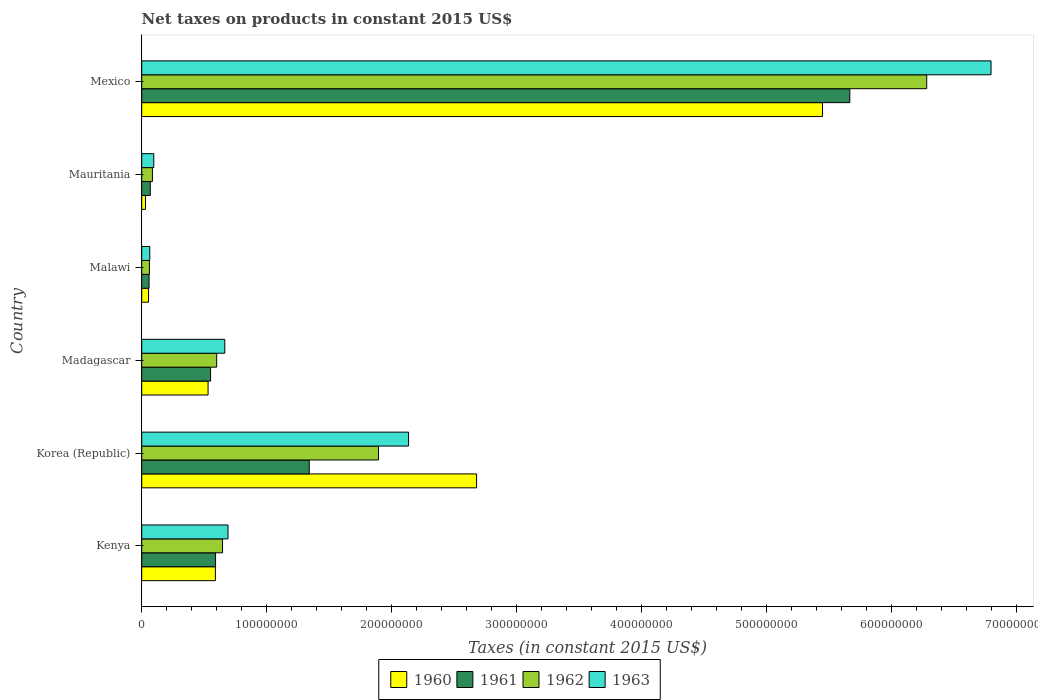How many groups of bars are there?
Provide a succinct answer. 6. Are the number of bars per tick equal to the number of legend labels?
Ensure brevity in your answer.  Yes. How many bars are there on the 6th tick from the top?
Offer a terse response. 4. How many bars are there on the 2nd tick from the bottom?
Keep it short and to the point. 4. In how many cases, is the number of bars for a given country not equal to the number of legend labels?
Keep it short and to the point. 0. What is the net taxes on products in 1960 in Mauritania?
Your answer should be compact. 3.00e+06. Across all countries, what is the maximum net taxes on products in 1962?
Your answer should be very brief. 6.28e+08. Across all countries, what is the minimum net taxes on products in 1960?
Keep it short and to the point. 3.00e+06. In which country was the net taxes on products in 1960 maximum?
Make the answer very short. Mexico. In which country was the net taxes on products in 1960 minimum?
Offer a terse response. Mauritania. What is the total net taxes on products in 1961 in the graph?
Make the answer very short. 8.27e+08. What is the difference between the net taxes on products in 1961 in Madagascar and that in Malawi?
Your answer should be very brief. 4.92e+07. What is the difference between the net taxes on products in 1961 in Korea (Republic) and the net taxes on products in 1962 in Madagascar?
Provide a succinct answer. 7.41e+07. What is the average net taxes on products in 1960 per country?
Give a very brief answer. 1.55e+08. What is the difference between the net taxes on products in 1962 and net taxes on products in 1960 in Kenya?
Your answer should be very brief. 5.73e+06. What is the ratio of the net taxes on products in 1961 in Malawi to that in Mexico?
Your answer should be compact. 0.01. Is the net taxes on products in 1960 in Madagascar less than that in Mauritania?
Offer a very short reply. No. What is the difference between the highest and the second highest net taxes on products in 1963?
Make the answer very short. 4.66e+08. What is the difference between the highest and the lowest net taxes on products in 1962?
Offer a very short reply. 6.22e+08. In how many countries, is the net taxes on products in 1962 greater than the average net taxes on products in 1962 taken over all countries?
Provide a short and direct response. 2. Is the sum of the net taxes on products in 1961 in Mauritania and Mexico greater than the maximum net taxes on products in 1960 across all countries?
Give a very brief answer. Yes. What does the 3rd bar from the top in Madagascar represents?
Your response must be concise. 1961. What does the 2nd bar from the bottom in Kenya represents?
Your response must be concise. 1961. Is it the case that in every country, the sum of the net taxes on products in 1962 and net taxes on products in 1963 is greater than the net taxes on products in 1960?
Ensure brevity in your answer.  Yes. How many bars are there?
Give a very brief answer. 24. What is the difference between two consecutive major ticks on the X-axis?
Make the answer very short. 1.00e+08. Does the graph contain any zero values?
Provide a succinct answer. No. Does the graph contain grids?
Give a very brief answer. No. Where does the legend appear in the graph?
Your response must be concise. Bottom center. How are the legend labels stacked?
Your answer should be very brief. Horizontal. What is the title of the graph?
Your answer should be very brief. Net taxes on products in constant 2015 US$. Does "2000" appear as one of the legend labels in the graph?
Provide a short and direct response. No. What is the label or title of the X-axis?
Keep it short and to the point. Taxes (in constant 2015 US$). What is the label or title of the Y-axis?
Offer a very short reply. Country. What is the Taxes (in constant 2015 US$) of 1960 in Kenya?
Give a very brief answer. 5.89e+07. What is the Taxes (in constant 2015 US$) of 1961 in Kenya?
Ensure brevity in your answer.  5.91e+07. What is the Taxes (in constant 2015 US$) of 1962 in Kenya?
Offer a very short reply. 6.47e+07. What is the Taxes (in constant 2015 US$) in 1963 in Kenya?
Ensure brevity in your answer.  6.90e+07. What is the Taxes (in constant 2015 US$) of 1960 in Korea (Republic)?
Make the answer very short. 2.68e+08. What is the Taxes (in constant 2015 US$) of 1961 in Korea (Republic)?
Keep it short and to the point. 1.34e+08. What is the Taxes (in constant 2015 US$) in 1962 in Korea (Republic)?
Keep it short and to the point. 1.89e+08. What is the Taxes (in constant 2015 US$) in 1963 in Korea (Republic)?
Your answer should be very brief. 2.13e+08. What is the Taxes (in constant 2015 US$) of 1960 in Madagascar?
Keep it short and to the point. 5.31e+07. What is the Taxes (in constant 2015 US$) in 1961 in Madagascar?
Offer a very short reply. 5.51e+07. What is the Taxes (in constant 2015 US$) in 1962 in Madagascar?
Keep it short and to the point. 6.00e+07. What is the Taxes (in constant 2015 US$) of 1963 in Madagascar?
Ensure brevity in your answer.  6.64e+07. What is the Taxes (in constant 2015 US$) in 1960 in Malawi?
Ensure brevity in your answer.  5.46e+06. What is the Taxes (in constant 2015 US$) of 1961 in Malawi?
Your answer should be compact. 5.88e+06. What is the Taxes (in constant 2015 US$) in 1962 in Malawi?
Provide a succinct answer. 6.16e+06. What is the Taxes (in constant 2015 US$) in 1963 in Malawi?
Make the answer very short. 6.44e+06. What is the Taxes (in constant 2015 US$) of 1960 in Mauritania?
Your response must be concise. 3.00e+06. What is the Taxes (in constant 2015 US$) of 1961 in Mauritania?
Offer a terse response. 6.85e+06. What is the Taxes (in constant 2015 US$) in 1962 in Mauritania?
Offer a terse response. 8.56e+06. What is the Taxes (in constant 2015 US$) of 1963 in Mauritania?
Make the answer very short. 9.63e+06. What is the Taxes (in constant 2015 US$) of 1960 in Mexico?
Give a very brief answer. 5.45e+08. What is the Taxes (in constant 2015 US$) of 1961 in Mexico?
Provide a succinct answer. 5.66e+08. What is the Taxes (in constant 2015 US$) in 1962 in Mexico?
Your response must be concise. 6.28e+08. What is the Taxes (in constant 2015 US$) of 1963 in Mexico?
Provide a succinct answer. 6.79e+08. Across all countries, what is the maximum Taxes (in constant 2015 US$) of 1960?
Offer a very short reply. 5.45e+08. Across all countries, what is the maximum Taxes (in constant 2015 US$) of 1961?
Ensure brevity in your answer.  5.66e+08. Across all countries, what is the maximum Taxes (in constant 2015 US$) of 1962?
Your answer should be compact. 6.28e+08. Across all countries, what is the maximum Taxes (in constant 2015 US$) in 1963?
Make the answer very short. 6.79e+08. Across all countries, what is the minimum Taxes (in constant 2015 US$) in 1960?
Provide a succinct answer. 3.00e+06. Across all countries, what is the minimum Taxes (in constant 2015 US$) of 1961?
Ensure brevity in your answer.  5.88e+06. Across all countries, what is the minimum Taxes (in constant 2015 US$) of 1962?
Give a very brief answer. 6.16e+06. Across all countries, what is the minimum Taxes (in constant 2015 US$) in 1963?
Make the answer very short. 6.44e+06. What is the total Taxes (in constant 2015 US$) in 1960 in the graph?
Your answer should be compact. 9.33e+08. What is the total Taxes (in constant 2015 US$) of 1961 in the graph?
Offer a terse response. 8.27e+08. What is the total Taxes (in constant 2015 US$) of 1962 in the graph?
Give a very brief answer. 9.57e+08. What is the total Taxes (in constant 2015 US$) of 1963 in the graph?
Your answer should be compact. 1.04e+09. What is the difference between the Taxes (in constant 2015 US$) in 1960 in Kenya and that in Korea (Republic)?
Provide a short and direct response. -2.09e+08. What is the difference between the Taxes (in constant 2015 US$) of 1961 in Kenya and that in Korea (Republic)?
Give a very brief answer. -7.49e+07. What is the difference between the Taxes (in constant 2015 US$) in 1962 in Kenya and that in Korea (Republic)?
Offer a terse response. -1.25e+08. What is the difference between the Taxes (in constant 2015 US$) of 1963 in Kenya and that in Korea (Republic)?
Provide a succinct answer. -1.44e+08. What is the difference between the Taxes (in constant 2015 US$) in 1960 in Kenya and that in Madagascar?
Provide a short and direct response. 5.86e+06. What is the difference between the Taxes (in constant 2015 US$) in 1961 in Kenya and that in Madagascar?
Your answer should be compact. 3.97e+06. What is the difference between the Taxes (in constant 2015 US$) of 1962 in Kenya and that in Madagascar?
Your response must be concise. 4.70e+06. What is the difference between the Taxes (in constant 2015 US$) of 1963 in Kenya and that in Madagascar?
Your response must be concise. 2.58e+06. What is the difference between the Taxes (in constant 2015 US$) of 1960 in Kenya and that in Malawi?
Your response must be concise. 5.35e+07. What is the difference between the Taxes (in constant 2015 US$) of 1961 in Kenya and that in Malawi?
Ensure brevity in your answer.  5.32e+07. What is the difference between the Taxes (in constant 2015 US$) of 1962 in Kenya and that in Malawi?
Give a very brief answer. 5.85e+07. What is the difference between the Taxes (in constant 2015 US$) in 1963 in Kenya and that in Malawi?
Make the answer very short. 6.26e+07. What is the difference between the Taxes (in constant 2015 US$) in 1960 in Kenya and that in Mauritania?
Provide a short and direct response. 5.59e+07. What is the difference between the Taxes (in constant 2015 US$) in 1961 in Kenya and that in Mauritania?
Give a very brief answer. 5.22e+07. What is the difference between the Taxes (in constant 2015 US$) of 1962 in Kenya and that in Mauritania?
Offer a terse response. 5.61e+07. What is the difference between the Taxes (in constant 2015 US$) in 1963 in Kenya and that in Mauritania?
Offer a very short reply. 5.94e+07. What is the difference between the Taxes (in constant 2015 US$) of 1960 in Kenya and that in Mexico?
Your response must be concise. -4.86e+08. What is the difference between the Taxes (in constant 2015 US$) in 1961 in Kenya and that in Mexico?
Your response must be concise. -5.07e+08. What is the difference between the Taxes (in constant 2015 US$) of 1962 in Kenya and that in Mexico?
Make the answer very short. -5.63e+08. What is the difference between the Taxes (in constant 2015 US$) in 1963 in Kenya and that in Mexico?
Your answer should be very brief. -6.10e+08. What is the difference between the Taxes (in constant 2015 US$) of 1960 in Korea (Republic) and that in Madagascar?
Make the answer very short. 2.15e+08. What is the difference between the Taxes (in constant 2015 US$) of 1961 in Korea (Republic) and that in Madagascar?
Keep it short and to the point. 7.89e+07. What is the difference between the Taxes (in constant 2015 US$) of 1962 in Korea (Republic) and that in Madagascar?
Offer a terse response. 1.29e+08. What is the difference between the Taxes (in constant 2015 US$) in 1963 in Korea (Republic) and that in Madagascar?
Provide a short and direct response. 1.47e+08. What is the difference between the Taxes (in constant 2015 US$) of 1960 in Korea (Republic) and that in Malawi?
Your answer should be very brief. 2.62e+08. What is the difference between the Taxes (in constant 2015 US$) in 1961 in Korea (Republic) and that in Malawi?
Provide a succinct answer. 1.28e+08. What is the difference between the Taxes (in constant 2015 US$) in 1962 in Korea (Republic) and that in Malawi?
Offer a terse response. 1.83e+08. What is the difference between the Taxes (in constant 2015 US$) of 1963 in Korea (Republic) and that in Malawi?
Offer a very short reply. 2.07e+08. What is the difference between the Taxes (in constant 2015 US$) of 1960 in Korea (Republic) and that in Mauritania?
Provide a succinct answer. 2.65e+08. What is the difference between the Taxes (in constant 2015 US$) in 1961 in Korea (Republic) and that in Mauritania?
Ensure brevity in your answer.  1.27e+08. What is the difference between the Taxes (in constant 2015 US$) of 1962 in Korea (Republic) and that in Mauritania?
Your answer should be compact. 1.81e+08. What is the difference between the Taxes (in constant 2015 US$) in 1963 in Korea (Republic) and that in Mauritania?
Keep it short and to the point. 2.04e+08. What is the difference between the Taxes (in constant 2015 US$) in 1960 in Korea (Republic) and that in Mexico?
Your response must be concise. -2.77e+08. What is the difference between the Taxes (in constant 2015 US$) of 1961 in Korea (Republic) and that in Mexico?
Your answer should be very brief. -4.32e+08. What is the difference between the Taxes (in constant 2015 US$) in 1962 in Korea (Republic) and that in Mexico?
Your answer should be very brief. -4.38e+08. What is the difference between the Taxes (in constant 2015 US$) in 1963 in Korea (Republic) and that in Mexico?
Your answer should be very brief. -4.66e+08. What is the difference between the Taxes (in constant 2015 US$) of 1960 in Madagascar and that in Malawi?
Your response must be concise. 4.76e+07. What is the difference between the Taxes (in constant 2015 US$) of 1961 in Madagascar and that in Malawi?
Keep it short and to the point. 4.92e+07. What is the difference between the Taxes (in constant 2015 US$) of 1962 in Madagascar and that in Malawi?
Offer a very short reply. 5.38e+07. What is the difference between the Taxes (in constant 2015 US$) of 1963 in Madagascar and that in Malawi?
Make the answer very short. 6.00e+07. What is the difference between the Taxes (in constant 2015 US$) in 1960 in Madagascar and that in Mauritania?
Your response must be concise. 5.01e+07. What is the difference between the Taxes (in constant 2015 US$) in 1961 in Madagascar and that in Mauritania?
Provide a short and direct response. 4.82e+07. What is the difference between the Taxes (in constant 2015 US$) in 1962 in Madagascar and that in Mauritania?
Your answer should be very brief. 5.14e+07. What is the difference between the Taxes (in constant 2015 US$) in 1963 in Madagascar and that in Mauritania?
Keep it short and to the point. 5.68e+07. What is the difference between the Taxes (in constant 2015 US$) of 1960 in Madagascar and that in Mexico?
Offer a very short reply. -4.91e+08. What is the difference between the Taxes (in constant 2015 US$) of 1961 in Madagascar and that in Mexico?
Offer a very short reply. -5.11e+08. What is the difference between the Taxes (in constant 2015 US$) of 1962 in Madagascar and that in Mexico?
Your answer should be compact. -5.68e+08. What is the difference between the Taxes (in constant 2015 US$) of 1963 in Madagascar and that in Mexico?
Provide a short and direct response. -6.13e+08. What is the difference between the Taxes (in constant 2015 US$) in 1960 in Malawi and that in Mauritania?
Ensure brevity in your answer.  2.46e+06. What is the difference between the Taxes (in constant 2015 US$) in 1961 in Malawi and that in Mauritania?
Provide a succinct answer. -9.67e+05. What is the difference between the Taxes (in constant 2015 US$) in 1962 in Malawi and that in Mauritania?
Offer a terse response. -2.40e+06. What is the difference between the Taxes (in constant 2015 US$) of 1963 in Malawi and that in Mauritania?
Make the answer very short. -3.19e+06. What is the difference between the Taxes (in constant 2015 US$) in 1960 in Malawi and that in Mexico?
Make the answer very short. -5.39e+08. What is the difference between the Taxes (in constant 2015 US$) in 1961 in Malawi and that in Mexico?
Offer a very short reply. -5.61e+08. What is the difference between the Taxes (in constant 2015 US$) of 1962 in Malawi and that in Mexico?
Provide a short and direct response. -6.22e+08. What is the difference between the Taxes (in constant 2015 US$) in 1963 in Malawi and that in Mexico?
Provide a succinct answer. -6.73e+08. What is the difference between the Taxes (in constant 2015 US$) in 1960 in Mauritania and that in Mexico?
Offer a very short reply. -5.42e+08. What is the difference between the Taxes (in constant 2015 US$) of 1961 in Mauritania and that in Mexico?
Your answer should be compact. -5.60e+08. What is the difference between the Taxes (in constant 2015 US$) in 1962 in Mauritania and that in Mexico?
Ensure brevity in your answer.  -6.19e+08. What is the difference between the Taxes (in constant 2015 US$) of 1963 in Mauritania and that in Mexico?
Offer a terse response. -6.70e+08. What is the difference between the Taxes (in constant 2015 US$) in 1960 in Kenya and the Taxes (in constant 2015 US$) in 1961 in Korea (Republic)?
Ensure brevity in your answer.  -7.51e+07. What is the difference between the Taxes (in constant 2015 US$) in 1960 in Kenya and the Taxes (in constant 2015 US$) in 1962 in Korea (Republic)?
Ensure brevity in your answer.  -1.31e+08. What is the difference between the Taxes (in constant 2015 US$) in 1960 in Kenya and the Taxes (in constant 2015 US$) in 1963 in Korea (Republic)?
Provide a short and direct response. -1.55e+08. What is the difference between the Taxes (in constant 2015 US$) in 1961 in Kenya and the Taxes (in constant 2015 US$) in 1962 in Korea (Republic)?
Your answer should be compact. -1.30e+08. What is the difference between the Taxes (in constant 2015 US$) in 1961 in Kenya and the Taxes (in constant 2015 US$) in 1963 in Korea (Republic)?
Provide a short and direct response. -1.54e+08. What is the difference between the Taxes (in constant 2015 US$) of 1962 in Kenya and the Taxes (in constant 2015 US$) of 1963 in Korea (Republic)?
Provide a short and direct response. -1.49e+08. What is the difference between the Taxes (in constant 2015 US$) in 1960 in Kenya and the Taxes (in constant 2015 US$) in 1961 in Madagascar?
Provide a short and direct response. 3.83e+06. What is the difference between the Taxes (in constant 2015 US$) in 1960 in Kenya and the Taxes (in constant 2015 US$) in 1962 in Madagascar?
Ensure brevity in your answer.  -1.03e+06. What is the difference between the Taxes (in constant 2015 US$) in 1960 in Kenya and the Taxes (in constant 2015 US$) in 1963 in Madagascar?
Provide a short and direct response. -7.51e+06. What is the difference between the Taxes (in constant 2015 US$) in 1961 in Kenya and the Taxes (in constant 2015 US$) in 1962 in Madagascar?
Ensure brevity in your answer.  -8.90e+05. What is the difference between the Taxes (in constant 2015 US$) in 1961 in Kenya and the Taxes (in constant 2015 US$) in 1963 in Madagascar?
Ensure brevity in your answer.  -7.37e+06. What is the difference between the Taxes (in constant 2015 US$) of 1962 in Kenya and the Taxes (in constant 2015 US$) of 1963 in Madagascar?
Offer a very short reply. -1.79e+06. What is the difference between the Taxes (in constant 2015 US$) of 1960 in Kenya and the Taxes (in constant 2015 US$) of 1961 in Malawi?
Keep it short and to the point. 5.30e+07. What is the difference between the Taxes (in constant 2015 US$) of 1960 in Kenya and the Taxes (in constant 2015 US$) of 1962 in Malawi?
Your response must be concise. 5.28e+07. What is the difference between the Taxes (in constant 2015 US$) of 1960 in Kenya and the Taxes (in constant 2015 US$) of 1963 in Malawi?
Offer a terse response. 5.25e+07. What is the difference between the Taxes (in constant 2015 US$) in 1961 in Kenya and the Taxes (in constant 2015 US$) in 1962 in Malawi?
Give a very brief answer. 5.29e+07. What is the difference between the Taxes (in constant 2015 US$) in 1961 in Kenya and the Taxes (in constant 2015 US$) in 1963 in Malawi?
Make the answer very short. 5.26e+07. What is the difference between the Taxes (in constant 2015 US$) in 1962 in Kenya and the Taxes (in constant 2015 US$) in 1963 in Malawi?
Keep it short and to the point. 5.82e+07. What is the difference between the Taxes (in constant 2015 US$) in 1960 in Kenya and the Taxes (in constant 2015 US$) in 1961 in Mauritania?
Ensure brevity in your answer.  5.21e+07. What is the difference between the Taxes (in constant 2015 US$) of 1960 in Kenya and the Taxes (in constant 2015 US$) of 1962 in Mauritania?
Your answer should be compact. 5.04e+07. What is the difference between the Taxes (in constant 2015 US$) of 1960 in Kenya and the Taxes (in constant 2015 US$) of 1963 in Mauritania?
Offer a terse response. 4.93e+07. What is the difference between the Taxes (in constant 2015 US$) of 1961 in Kenya and the Taxes (in constant 2015 US$) of 1962 in Mauritania?
Keep it short and to the point. 5.05e+07. What is the difference between the Taxes (in constant 2015 US$) in 1961 in Kenya and the Taxes (in constant 2015 US$) in 1963 in Mauritania?
Make the answer very short. 4.94e+07. What is the difference between the Taxes (in constant 2015 US$) in 1962 in Kenya and the Taxes (in constant 2015 US$) in 1963 in Mauritania?
Offer a very short reply. 5.50e+07. What is the difference between the Taxes (in constant 2015 US$) of 1960 in Kenya and the Taxes (in constant 2015 US$) of 1961 in Mexico?
Provide a succinct answer. -5.07e+08. What is the difference between the Taxes (in constant 2015 US$) in 1960 in Kenya and the Taxes (in constant 2015 US$) in 1962 in Mexico?
Ensure brevity in your answer.  -5.69e+08. What is the difference between the Taxes (in constant 2015 US$) in 1960 in Kenya and the Taxes (in constant 2015 US$) in 1963 in Mexico?
Offer a very short reply. -6.20e+08. What is the difference between the Taxes (in constant 2015 US$) of 1961 in Kenya and the Taxes (in constant 2015 US$) of 1962 in Mexico?
Your response must be concise. -5.69e+08. What is the difference between the Taxes (in constant 2015 US$) in 1961 in Kenya and the Taxes (in constant 2015 US$) in 1963 in Mexico?
Give a very brief answer. -6.20e+08. What is the difference between the Taxes (in constant 2015 US$) of 1962 in Kenya and the Taxes (in constant 2015 US$) of 1963 in Mexico?
Your answer should be very brief. -6.15e+08. What is the difference between the Taxes (in constant 2015 US$) of 1960 in Korea (Republic) and the Taxes (in constant 2015 US$) of 1961 in Madagascar?
Your answer should be very brief. 2.13e+08. What is the difference between the Taxes (in constant 2015 US$) of 1960 in Korea (Republic) and the Taxes (in constant 2015 US$) of 1962 in Madagascar?
Provide a short and direct response. 2.08e+08. What is the difference between the Taxes (in constant 2015 US$) of 1960 in Korea (Republic) and the Taxes (in constant 2015 US$) of 1963 in Madagascar?
Give a very brief answer. 2.01e+08. What is the difference between the Taxes (in constant 2015 US$) in 1961 in Korea (Republic) and the Taxes (in constant 2015 US$) in 1962 in Madagascar?
Provide a succinct answer. 7.41e+07. What is the difference between the Taxes (in constant 2015 US$) of 1961 in Korea (Republic) and the Taxes (in constant 2015 US$) of 1963 in Madagascar?
Offer a very short reply. 6.76e+07. What is the difference between the Taxes (in constant 2015 US$) of 1962 in Korea (Republic) and the Taxes (in constant 2015 US$) of 1963 in Madagascar?
Give a very brief answer. 1.23e+08. What is the difference between the Taxes (in constant 2015 US$) in 1960 in Korea (Republic) and the Taxes (in constant 2015 US$) in 1961 in Malawi?
Ensure brevity in your answer.  2.62e+08. What is the difference between the Taxes (in constant 2015 US$) of 1960 in Korea (Republic) and the Taxes (in constant 2015 US$) of 1962 in Malawi?
Keep it short and to the point. 2.62e+08. What is the difference between the Taxes (in constant 2015 US$) in 1960 in Korea (Republic) and the Taxes (in constant 2015 US$) in 1963 in Malawi?
Your response must be concise. 2.61e+08. What is the difference between the Taxes (in constant 2015 US$) of 1961 in Korea (Republic) and the Taxes (in constant 2015 US$) of 1962 in Malawi?
Your answer should be compact. 1.28e+08. What is the difference between the Taxes (in constant 2015 US$) of 1961 in Korea (Republic) and the Taxes (in constant 2015 US$) of 1963 in Malawi?
Provide a succinct answer. 1.28e+08. What is the difference between the Taxes (in constant 2015 US$) of 1962 in Korea (Republic) and the Taxes (in constant 2015 US$) of 1963 in Malawi?
Your answer should be compact. 1.83e+08. What is the difference between the Taxes (in constant 2015 US$) in 1960 in Korea (Republic) and the Taxes (in constant 2015 US$) in 1961 in Mauritania?
Your answer should be very brief. 2.61e+08. What is the difference between the Taxes (in constant 2015 US$) in 1960 in Korea (Republic) and the Taxes (in constant 2015 US$) in 1962 in Mauritania?
Your answer should be compact. 2.59e+08. What is the difference between the Taxes (in constant 2015 US$) in 1960 in Korea (Republic) and the Taxes (in constant 2015 US$) in 1963 in Mauritania?
Keep it short and to the point. 2.58e+08. What is the difference between the Taxes (in constant 2015 US$) in 1961 in Korea (Republic) and the Taxes (in constant 2015 US$) in 1962 in Mauritania?
Offer a very short reply. 1.25e+08. What is the difference between the Taxes (in constant 2015 US$) in 1961 in Korea (Republic) and the Taxes (in constant 2015 US$) in 1963 in Mauritania?
Provide a short and direct response. 1.24e+08. What is the difference between the Taxes (in constant 2015 US$) in 1962 in Korea (Republic) and the Taxes (in constant 2015 US$) in 1963 in Mauritania?
Provide a short and direct response. 1.80e+08. What is the difference between the Taxes (in constant 2015 US$) of 1960 in Korea (Republic) and the Taxes (in constant 2015 US$) of 1961 in Mexico?
Give a very brief answer. -2.99e+08. What is the difference between the Taxes (in constant 2015 US$) in 1960 in Korea (Republic) and the Taxes (in constant 2015 US$) in 1962 in Mexico?
Provide a succinct answer. -3.60e+08. What is the difference between the Taxes (in constant 2015 US$) of 1960 in Korea (Republic) and the Taxes (in constant 2015 US$) of 1963 in Mexico?
Ensure brevity in your answer.  -4.12e+08. What is the difference between the Taxes (in constant 2015 US$) in 1961 in Korea (Republic) and the Taxes (in constant 2015 US$) in 1962 in Mexico?
Make the answer very short. -4.94e+08. What is the difference between the Taxes (in constant 2015 US$) of 1961 in Korea (Republic) and the Taxes (in constant 2015 US$) of 1963 in Mexico?
Keep it short and to the point. -5.45e+08. What is the difference between the Taxes (in constant 2015 US$) in 1962 in Korea (Republic) and the Taxes (in constant 2015 US$) in 1963 in Mexico?
Your answer should be very brief. -4.90e+08. What is the difference between the Taxes (in constant 2015 US$) of 1960 in Madagascar and the Taxes (in constant 2015 US$) of 1961 in Malawi?
Give a very brief answer. 4.72e+07. What is the difference between the Taxes (in constant 2015 US$) in 1960 in Madagascar and the Taxes (in constant 2015 US$) in 1962 in Malawi?
Make the answer very short. 4.69e+07. What is the difference between the Taxes (in constant 2015 US$) of 1960 in Madagascar and the Taxes (in constant 2015 US$) of 1963 in Malawi?
Provide a succinct answer. 4.66e+07. What is the difference between the Taxes (in constant 2015 US$) of 1961 in Madagascar and the Taxes (in constant 2015 US$) of 1962 in Malawi?
Keep it short and to the point. 4.89e+07. What is the difference between the Taxes (in constant 2015 US$) in 1961 in Madagascar and the Taxes (in constant 2015 US$) in 1963 in Malawi?
Provide a short and direct response. 4.87e+07. What is the difference between the Taxes (in constant 2015 US$) in 1962 in Madagascar and the Taxes (in constant 2015 US$) in 1963 in Malawi?
Provide a succinct answer. 5.35e+07. What is the difference between the Taxes (in constant 2015 US$) in 1960 in Madagascar and the Taxes (in constant 2015 US$) in 1961 in Mauritania?
Your answer should be compact. 4.62e+07. What is the difference between the Taxes (in constant 2015 US$) of 1960 in Madagascar and the Taxes (in constant 2015 US$) of 1962 in Mauritania?
Keep it short and to the point. 4.45e+07. What is the difference between the Taxes (in constant 2015 US$) in 1960 in Madagascar and the Taxes (in constant 2015 US$) in 1963 in Mauritania?
Your answer should be compact. 4.34e+07. What is the difference between the Taxes (in constant 2015 US$) of 1961 in Madagascar and the Taxes (in constant 2015 US$) of 1962 in Mauritania?
Your answer should be compact. 4.65e+07. What is the difference between the Taxes (in constant 2015 US$) in 1961 in Madagascar and the Taxes (in constant 2015 US$) in 1963 in Mauritania?
Your answer should be very brief. 4.55e+07. What is the difference between the Taxes (in constant 2015 US$) of 1962 in Madagascar and the Taxes (in constant 2015 US$) of 1963 in Mauritania?
Your response must be concise. 5.03e+07. What is the difference between the Taxes (in constant 2015 US$) of 1960 in Madagascar and the Taxes (in constant 2015 US$) of 1961 in Mexico?
Provide a succinct answer. -5.13e+08. What is the difference between the Taxes (in constant 2015 US$) of 1960 in Madagascar and the Taxes (in constant 2015 US$) of 1962 in Mexico?
Offer a terse response. -5.75e+08. What is the difference between the Taxes (in constant 2015 US$) in 1960 in Madagascar and the Taxes (in constant 2015 US$) in 1963 in Mexico?
Make the answer very short. -6.26e+08. What is the difference between the Taxes (in constant 2015 US$) of 1961 in Madagascar and the Taxes (in constant 2015 US$) of 1962 in Mexico?
Offer a terse response. -5.73e+08. What is the difference between the Taxes (in constant 2015 US$) of 1961 in Madagascar and the Taxes (in constant 2015 US$) of 1963 in Mexico?
Offer a terse response. -6.24e+08. What is the difference between the Taxes (in constant 2015 US$) of 1962 in Madagascar and the Taxes (in constant 2015 US$) of 1963 in Mexico?
Give a very brief answer. -6.19e+08. What is the difference between the Taxes (in constant 2015 US$) in 1960 in Malawi and the Taxes (in constant 2015 US$) in 1961 in Mauritania?
Give a very brief answer. -1.39e+06. What is the difference between the Taxes (in constant 2015 US$) in 1960 in Malawi and the Taxes (in constant 2015 US$) in 1962 in Mauritania?
Keep it short and to the point. -3.10e+06. What is the difference between the Taxes (in constant 2015 US$) in 1960 in Malawi and the Taxes (in constant 2015 US$) in 1963 in Mauritania?
Make the answer very short. -4.17e+06. What is the difference between the Taxes (in constant 2015 US$) of 1961 in Malawi and the Taxes (in constant 2015 US$) of 1962 in Mauritania?
Provide a short and direct response. -2.68e+06. What is the difference between the Taxes (in constant 2015 US$) of 1961 in Malawi and the Taxes (in constant 2015 US$) of 1963 in Mauritania?
Your answer should be very brief. -3.75e+06. What is the difference between the Taxes (in constant 2015 US$) of 1962 in Malawi and the Taxes (in constant 2015 US$) of 1963 in Mauritania?
Provide a short and direct response. -3.47e+06. What is the difference between the Taxes (in constant 2015 US$) in 1960 in Malawi and the Taxes (in constant 2015 US$) in 1961 in Mexico?
Your answer should be compact. -5.61e+08. What is the difference between the Taxes (in constant 2015 US$) in 1960 in Malawi and the Taxes (in constant 2015 US$) in 1962 in Mexico?
Provide a short and direct response. -6.22e+08. What is the difference between the Taxes (in constant 2015 US$) in 1960 in Malawi and the Taxes (in constant 2015 US$) in 1963 in Mexico?
Make the answer very short. -6.74e+08. What is the difference between the Taxes (in constant 2015 US$) in 1961 in Malawi and the Taxes (in constant 2015 US$) in 1962 in Mexico?
Provide a succinct answer. -6.22e+08. What is the difference between the Taxes (in constant 2015 US$) of 1961 in Malawi and the Taxes (in constant 2015 US$) of 1963 in Mexico?
Ensure brevity in your answer.  -6.73e+08. What is the difference between the Taxes (in constant 2015 US$) in 1962 in Malawi and the Taxes (in constant 2015 US$) in 1963 in Mexico?
Ensure brevity in your answer.  -6.73e+08. What is the difference between the Taxes (in constant 2015 US$) in 1960 in Mauritania and the Taxes (in constant 2015 US$) in 1961 in Mexico?
Provide a short and direct response. -5.63e+08. What is the difference between the Taxes (in constant 2015 US$) of 1960 in Mauritania and the Taxes (in constant 2015 US$) of 1962 in Mexico?
Keep it short and to the point. -6.25e+08. What is the difference between the Taxes (in constant 2015 US$) in 1960 in Mauritania and the Taxes (in constant 2015 US$) in 1963 in Mexico?
Your answer should be compact. -6.76e+08. What is the difference between the Taxes (in constant 2015 US$) of 1961 in Mauritania and the Taxes (in constant 2015 US$) of 1962 in Mexico?
Offer a terse response. -6.21e+08. What is the difference between the Taxes (in constant 2015 US$) in 1961 in Mauritania and the Taxes (in constant 2015 US$) in 1963 in Mexico?
Provide a short and direct response. -6.73e+08. What is the difference between the Taxes (in constant 2015 US$) in 1962 in Mauritania and the Taxes (in constant 2015 US$) in 1963 in Mexico?
Provide a succinct answer. -6.71e+08. What is the average Taxes (in constant 2015 US$) of 1960 per country?
Offer a very short reply. 1.55e+08. What is the average Taxes (in constant 2015 US$) of 1961 per country?
Your answer should be compact. 1.38e+08. What is the average Taxes (in constant 2015 US$) in 1962 per country?
Ensure brevity in your answer.  1.59e+08. What is the average Taxes (in constant 2015 US$) in 1963 per country?
Make the answer very short. 1.74e+08. What is the difference between the Taxes (in constant 2015 US$) of 1960 and Taxes (in constant 2015 US$) of 1961 in Kenya?
Give a very brief answer. -1.40e+05. What is the difference between the Taxes (in constant 2015 US$) of 1960 and Taxes (in constant 2015 US$) of 1962 in Kenya?
Ensure brevity in your answer.  -5.73e+06. What is the difference between the Taxes (in constant 2015 US$) in 1960 and Taxes (in constant 2015 US$) in 1963 in Kenya?
Offer a very short reply. -1.01e+07. What is the difference between the Taxes (in constant 2015 US$) of 1961 and Taxes (in constant 2015 US$) of 1962 in Kenya?
Your response must be concise. -5.59e+06. What is the difference between the Taxes (in constant 2015 US$) in 1961 and Taxes (in constant 2015 US$) in 1963 in Kenya?
Your answer should be compact. -9.95e+06. What is the difference between the Taxes (in constant 2015 US$) in 1962 and Taxes (in constant 2015 US$) in 1963 in Kenya?
Make the answer very short. -4.37e+06. What is the difference between the Taxes (in constant 2015 US$) in 1960 and Taxes (in constant 2015 US$) in 1961 in Korea (Republic)?
Offer a terse response. 1.34e+08. What is the difference between the Taxes (in constant 2015 US$) of 1960 and Taxes (in constant 2015 US$) of 1962 in Korea (Republic)?
Ensure brevity in your answer.  7.84e+07. What is the difference between the Taxes (in constant 2015 US$) in 1960 and Taxes (in constant 2015 US$) in 1963 in Korea (Republic)?
Ensure brevity in your answer.  5.44e+07. What is the difference between the Taxes (in constant 2015 US$) in 1961 and Taxes (in constant 2015 US$) in 1962 in Korea (Republic)?
Your answer should be very brief. -5.54e+07. What is the difference between the Taxes (in constant 2015 US$) of 1961 and Taxes (in constant 2015 US$) of 1963 in Korea (Republic)?
Ensure brevity in your answer.  -7.94e+07. What is the difference between the Taxes (in constant 2015 US$) in 1962 and Taxes (in constant 2015 US$) in 1963 in Korea (Republic)?
Your answer should be compact. -2.40e+07. What is the difference between the Taxes (in constant 2015 US$) of 1960 and Taxes (in constant 2015 US$) of 1961 in Madagascar?
Your response must be concise. -2.03e+06. What is the difference between the Taxes (in constant 2015 US$) of 1960 and Taxes (in constant 2015 US$) of 1962 in Madagascar?
Your answer should be compact. -6.89e+06. What is the difference between the Taxes (in constant 2015 US$) in 1960 and Taxes (in constant 2015 US$) in 1963 in Madagascar?
Provide a short and direct response. -1.34e+07. What is the difference between the Taxes (in constant 2015 US$) of 1961 and Taxes (in constant 2015 US$) of 1962 in Madagascar?
Provide a short and direct response. -4.86e+06. What is the difference between the Taxes (in constant 2015 US$) in 1961 and Taxes (in constant 2015 US$) in 1963 in Madagascar?
Keep it short and to the point. -1.13e+07. What is the difference between the Taxes (in constant 2015 US$) in 1962 and Taxes (in constant 2015 US$) in 1963 in Madagascar?
Keep it short and to the point. -6.48e+06. What is the difference between the Taxes (in constant 2015 US$) of 1960 and Taxes (in constant 2015 US$) of 1961 in Malawi?
Offer a very short reply. -4.20e+05. What is the difference between the Taxes (in constant 2015 US$) in 1960 and Taxes (in constant 2015 US$) in 1962 in Malawi?
Ensure brevity in your answer.  -7.00e+05. What is the difference between the Taxes (in constant 2015 US$) of 1960 and Taxes (in constant 2015 US$) of 1963 in Malawi?
Offer a very short reply. -9.80e+05. What is the difference between the Taxes (in constant 2015 US$) of 1961 and Taxes (in constant 2015 US$) of 1962 in Malawi?
Ensure brevity in your answer.  -2.80e+05. What is the difference between the Taxes (in constant 2015 US$) in 1961 and Taxes (in constant 2015 US$) in 1963 in Malawi?
Ensure brevity in your answer.  -5.60e+05. What is the difference between the Taxes (in constant 2015 US$) of 1962 and Taxes (in constant 2015 US$) of 1963 in Malawi?
Your answer should be very brief. -2.80e+05. What is the difference between the Taxes (in constant 2015 US$) in 1960 and Taxes (in constant 2015 US$) in 1961 in Mauritania?
Your response must be concise. -3.85e+06. What is the difference between the Taxes (in constant 2015 US$) in 1960 and Taxes (in constant 2015 US$) in 1962 in Mauritania?
Offer a terse response. -5.56e+06. What is the difference between the Taxes (in constant 2015 US$) in 1960 and Taxes (in constant 2015 US$) in 1963 in Mauritania?
Provide a succinct answer. -6.63e+06. What is the difference between the Taxes (in constant 2015 US$) in 1961 and Taxes (in constant 2015 US$) in 1962 in Mauritania?
Offer a terse response. -1.71e+06. What is the difference between the Taxes (in constant 2015 US$) of 1961 and Taxes (in constant 2015 US$) of 1963 in Mauritania?
Provide a succinct answer. -2.78e+06. What is the difference between the Taxes (in constant 2015 US$) in 1962 and Taxes (in constant 2015 US$) in 1963 in Mauritania?
Offer a very short reply. -1.07e+06. What is the difference between the Taxes (in constant 2015 US$) of 1960 and Taxes (in constant 2015 US$) of 1961 in Mexico?
Provide a short and direct response. -2.18e+07. What is the difference between the Taxes (in constant 2015 US$) of 1960 and Taxes (in constant 2015 US$) of 1962 in Mexico?
Your answer should be compact. -8.34e+07. What is the difference between the Taxes (in constant 2015 US$) of 1960 and Taxes (in constant 2015 US$) of 1963 in Mexico?
Provide a succinct answer. -1.35e+08. What is the difference between the Taxes (in constant 2015 US$) in 1961 and Taxes (in constant 2015 US$) in 1962 in Mexico?
Your response must be concise. -6.15e+07. What is the difference between the Taxes (in constant 2015 US$) in 1961 and Taxes (in constant 2015 US$) in 1963 in Mexico?
Your answer should be compact. -1.13e+08. What is the difference between the Taxes (in constant 2015 US$) of 1962 and Taxes (in constant 2015 US$) of 1963 in Mexico?
Your answer should be very brief. -5.14e+07. What is the ratio of the Taxes (in constant 2015 US$) of 1960 in Kenya to that in Korea (Republic)?
Make the answer very short. 0.22. What is the ratio of the Taxes (in constant 2015 US$) in 1961 in Kenya to that in Korea (Republic)?
Offer a very short reply. 0.44. What is the ratio of the Taxes (in constant 2015 US$) of 1962 in Kenya to that in Korea (Republic)?
Your answer should be compact. 0.34. What is the ratio of the Taxes (in constant 2015 US$) in 1963 in Kenya to that in Korea (Republic)?
Your answer should be very brief. 0.32. What is the ratio of the Taxes (in constant 2015 US$) in 1960 in Kenya to that in Madagascar?
Make the answer very short. 1.11. What is the ratio of the Taxes (in constant 2015 US$) of 1961 in Kenya to that in Madagascar?
Offer a very short reply. 1.07. What is the ratio of the Taxes (in constant 2015 US$) of 1962 in Kenya to that in Madagascar?
Provide a short and direct response. 1.08. What is the ratio of the Taxes (in constant 2015 US$) of 1963 in Kenya to that in Madagascar?
Give a very brief answer. 1.04. What is the ratio of the Taxes (in constant 2015 US$) in 1960 in Kenya to that in Malawi?
Your answer should be very brief. 10.79. What is the ratio of the Taxes (in constant 2015 US$) in 1961 in Kenya to that in Malawi?
Make the answer very short. 10.05. What is the ratio of the Taxes (in constant 2015 US$) of 1962 in Kenya to that in Malawi?
Offer a very short reply. 10.5. What is the ratio of the Taxes (in constant 2015 US$) of 1963 in Kenya to that in Malawi?
Your answer should be compact. 10.72. What is the ratio of the Taxes (in constant 2015 US$) in 1960 in Kenya to that in Mauritania?
Offer a very short reply. 19.67. What is the ratio of the Taxes (in constant 2015 US$) of 1961 in Kenya to that in Mauritania?
Make the answer very short. 8.63. What is the ratio of the Taxes (in constant 2015 US$) in 1962 in Kenya to that in Mauritania?
Provide a short and direct response. 7.55. What is the ratio of the Taxes (in constant 2015 US$) in 1963 in Kenya to that in Mauritania?
Your answer should be compact. 7.17. What is the ratio of the Taxes (in constant 2015 US$) of 1960 in Kenya to that in Mexico?
Ensure brevity in your answer.  0.11. What is the ratio of the Taxes (in constant 2015 US$) of 1961 in Kenya to that in Mexico?
Provide a short and direct response. 0.1. What is the ratio of the Taxes (in constant 2015 US$) in 1962 in Kenya to that in Mexico?
Give a very brief answer. 0.1. What is the ratio of the Taxes (in constant 2015 US$) of 1963 in Kenya to that in Mexico?
Your answer should be very brief. 0.1. What is the ratio of the Taxes (in constant 2015 US$) of 1960 in Korea (Republic) to that in Madagascar?
Your answer should be compact. 5.05. What is the ratio of the Taxes (in constant 2015 US$) of 1961 in Korea (Republic) to that in Madagascar?
Offer a very short reply. 2.43. What is the ratio of the Taxes (in constant 2015 US$) of 1962 in Korea (Republic) to that in Madagascar?
Your answer should be compact. 3.16. What is the ratio of the Taxes (in constant 2015 US$) of 1963 in Korea (Republic) to that in Madagascar?
Your answer should be compact. 3.21. What is the ratio of the Taxes (in constant 2015 US$) in 1960 in Korea (Republic) to that in Malawi?
Keep it short and to the point. 49.05. What is the ratio of the Taxes (in constant 2015 US$) of 1961 in Korea (Republic) to that in Malawi?
Ensure brevity in your answer.  22.79. What is the ratio of the Taxes (in constant 2015 US$) of 1962 in Korea (Republic) to that in Malawi?
Your answer should be very brief. 30.75. What is the ratio of the Taxes (in constant 2015 US$) of 1963 in Korea (Republic) to that in Malawi?
Offer a very short reply. 33.15. What is the ratio of the Taxes (in constant 2015 US$) of 1960 in Korea (Republic) to that in Mauritania?
Make the answer very short. 89.41. What is the ratio of the Taxes (in constant 2015 US$) of 1961 in Korea (Republic) to that in Mauritania?
Provide a succinct answer. 19.57. What is the ratio of the Taxes (in constant 2015 US$) of 1962 in Korea (Republic) to that in Mauritania?
Your response must be concise. 22.13. What is the ratio of the Taxes (in constant 2015 US$) of 1963 in Korea (Republic) to that in Mauritania?
Keep it short and to the point. 22.17. What is the ratio of the Taxes (in constant 2015 US$) in 1960 in Korea (Republic) to that in Mexico?
Provide a short and direct response. 0.49. What is the ratio of the Taxes (in constant 2015 US$) of 1961 in Korea (Republic) to that in Mexico?
Your response must be concise. 0.24. What is the ratio of the Taxes (in constant 2015 US$) of 1962 in Korea (Republic) to that in Mexico?
Make the answer very short. 0.3. What is the ratio of the Taxes (in constant 2015 US$) of 1963 in Korea (Republic) to that in Mexico?
Make the answer very short. 0.31. What is the ratio of the Taxes (in constant 2015 US$) in 1960 in Madagascar to that in Malawi?
Offer a very short reply. 9.72. What is the ratio of the Taxes (in constant 2015 US$) of 1961 in Madagascar to that in Malawi?
Give a very brief answer. 9.37. What is the ratio of the Taxes (in constant 2015 US$) of 1962 in Madagascar to that in Malawi?
Offer a terse response. 9.73. What is the ratio of the Taxes (in constant 2015 US$) of 1963 in Madagascar to that in Malawi?
Your answer should be compact. 10.32. What is the ratio of the Taxes (in constant 2015 US$) of 1960 in Madagascar to that in Mauritania?
Your answer should be very brief. 17.72. What is the ratio of the Taxes (in constant 2015 US$) of 1961 in Madagascar to that in Mauritania?
Provide a succinct answer. 8.05. What is the ratio of the Taxes (in constant 2015 US$) of 1962 in Madagascar to that in Mauritania?
Provide a succinct answer. 7. What is the ratio of the Taxes (in constant 2015 US$) of 1963 in Madagascar to that in Mauritania?
Make the answer very short. 6.9. What is the ratio of the Taxes (in constant 2015 US$) of 1960 in Madagascar to that in Mexico?
Offer a terse response. 0.1. What is the ratio of the Taxes (in constant 2015 US$) of 1961 in Madagascar to that in Mexico?
Provide a succinct answer. 0.1. What is the ratio of the Taxes (in constant 2015 US$) of 1962 in Madagascar to that in Mexico?
Your answer should be compact. 0.1. What is the ratio of the Taxes (in constant 2015 US$) in 1963 in Madagascar to that in Mexico?
Give a very brief answer. 0.1. What is the ratio of the Taxes (in constant 2015 US$) of 1960 in Malawi to that in Mauritania?
Offer a very short reply. 1.82. What is the ratio of the Taxes (in constant 2015 US$) in 1961 in Malawi to that in Mauritania?
Give a very brief answer. 0.86. What is the ratio of the Taxes (in constant 2015 US$) in 1962 in Malawi to that in Mauritania?
Provide a succinct answer. 0.72. What is the ratio of the Taxes (in constant 2015 US$) in 1963 in Malawi to that in Mauritania?
Provide a short and direct response. 0.67. What is the ratio of the Taxes (in constant 2015 US$) of 1960 in Malawi to that in Mexico?
Your answer should be compact. 0.01. What is the ratio of the Taxes (in constant 2015 US$) of 1961 in Malawi to that in Mexico?
Your answer should be very brief. 0.01. What is the ratio of the Taxes (in constant 2015 US$) in 1962 in Malawi to that in Mexico?
Offer a very short reply. 0.01. What is the ratio of the Taxes (in constant 2015 US$) in 1963 in Malawi to that in Mexico?
Give a very brief answer. 0.01. What is the ratio of the Taxes (in constant 2015 US$) in 1960 in Mauritania to that in Mexico?
Ensure brevity in your answer.  0.01. What is the ratio of the Taxes (in constant 2015 US$) in 1961 in Mauritania to that in Mexico?
Offer a terse response. 0.01. What is the ratio of the Taxes (in constant 2015 US$) in 1962 in Mauritania to that in Mexico?
Provide a short and direct response. 0.01. What is the ratio of the Taxes (in constant 2015 US$) in 1963 in Mauritania to that in Mexico?
Provide a succinct answer. 0.01. What is the difference between the highest and the second highest Taxes (in constant 2015 US$) in 1960?
Provide a short and direct response. 2.77e+08. What is the difference between the highest and the second highest Taxes (in constant 2015 US$) of 1961?
Your answer should be very brief. 4.32e+08. What is the difference between the highest and the second highest Taxes (in constant 2015 US$) of 1962?
Make the answer very short. 4.38e+08. What is the difference between the highest and the second highest Taxes (in constant 2015 US$) of 1963?
Provide a succinct answer. 4.66e+08. What is the difference between the highest and the lowest Taxes (in constant 2015 US$) in 1960?
Your response must be concise. 5.42e+08. What is the difference between the highest and the lowest Taxes (in constant 2015 US$) in 1961?
Offer a terse response. 5.61e+08. What is the difference between the highest and the lowest Taxes (in constant 2015 US$) in 1962?
Provide a short and direct response. 6.22e+08. What is the difference between the highest and the lowest Taxes (in constant 2015 US$) of 1963?
Your answer should be very brief. 6.73e+08. 